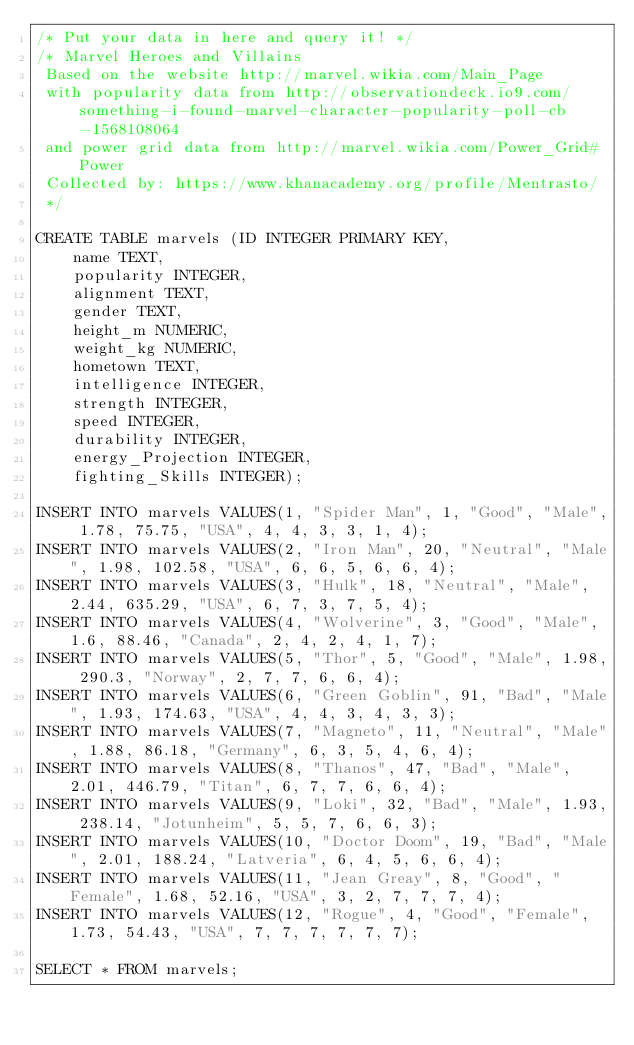<code> <loc_0><loc_0><loc_500><loc_500><_SQL_>/* Put your data in here and query it! */
/* Marvel Heroes and Villains
 Based on the website http://marvel.wikia.com/Main_Page
 with popularity data from http://observationdeck.io9.com/something-i-found-marvel-character-popularity-poll-cb-1568108064
 and power grid data from http://marvel.wikia.com/Power_Grid#Power
 Collected by: https://www.khanacademy.org/profile/Mentrasto/
 */

CREATE TABLE marvels (ID INTEGER PRIMARY KEY,
    name TEXT,
    popularity INTEGER,
    alignment TEXT,
    gender TEXT,
    height_m NUMERIC,
    weight_kg NUMERIC,
    hometown TEXT,
    intelligence INTEGER,
    strength INTEGER,
    speed INTEGER,
    durability INTEGER,
    energy_Projection INTEGER,
    fighting_Skills INTEGER);

INSERT INTO marvels VALUES(1, "Spider Man", 1, "Good", "Male", 1.78, 75.75, "USA", 4, 4, 3, 3, 1, 4);
INSERT INTO marvels VALUES(2, "Iron Man", 20, "Neutral", "Male", 1.98, 102.58, "USA", 6, 6, 5, 6, 6, 4);
INSERT INTO marvels VALUES(3, "Hulk", 18, "Neutral", "Male", 2.44, 635.29, "USA", 6, 7, 3, 7, 5, 4);
INSERT INTO marvels VALUES(4, "Wolverine", 3, "Good", "Male", 1.6, 88.46, "Canada", 2, 4, 2, 4, 1, 7);
INSERT INTO marvels VALUES(5, "Thor", 5, "Good", "Male", 1.98, 290.3, "Norway", 2, 7, 7, 6, 6, 4);
INSERT INTO marvels VALUES(6, "Green Goblin", 91, "Bad", "Male", 1.93, 174.63, "USA", 4, 4, 3, 4, 3, 3);
INSERT INTO marvels VALUES(7, "Magneto", 11, "Neutral", "Male", 1.88, 86.18, "Germany", 6, 3, 5, 4, 6, 4);
INSERT INTO marvels VALUES(8, "Thanos", 47, "Bad", "Male", 2.01, 446.79, "Titan", 6, 7, 7, 6, 6, 4);
INSERT INTO marvels VALUES(9, "Loki", 32, "Bad", "Male", 1.93, 238.14, "Jotunheim", 5, 5, 7, 6, 6, 3);
INSERT INTO marvels VALUES(10, "Doctor Doom", 19, "Bad", "Male", 2.01, 188.24, "Latveria", 6, 4, 5, 6, 6, 4);
INSERT INTO marvels VALUES(11, "Jean Greay", 8, "Good", "Female", 1.68, 52.16, "USA", 3, 2, 7, 7, 7, 4);
INSERT INTO marvels VALUES(12, "Rogue", 4, "Good", "Female", 1.73, 54.43, "USA", 7, 7, 7, 7, 7, 7);

SELECT * FROM marvels;
</code> 